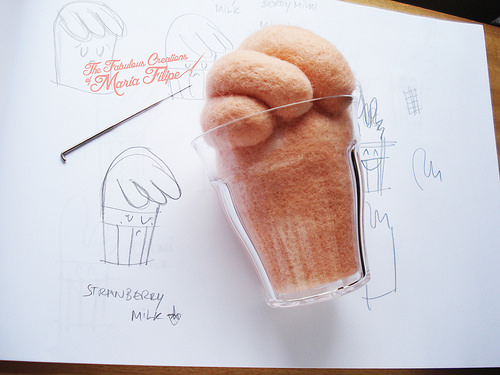<image>
Is the cup on the paper? Yes. Looking at the image, I can see the cup is positioned on top of the paper, with the paper providing support. Is the glass to the left of the paper? No. The glass is not to the left of the paper. From this viewpoint, they have a different horizontal relationship. 